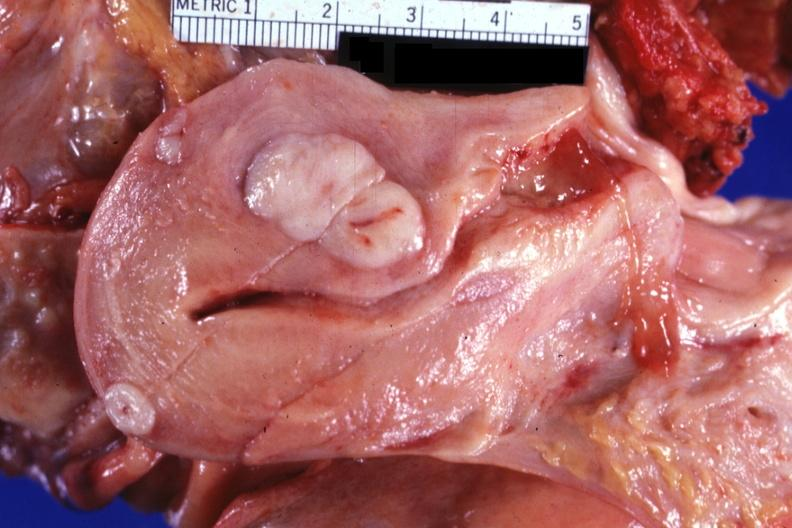where does this part belong to?
Answer the question using a single word or phrase. Female reproductive system 